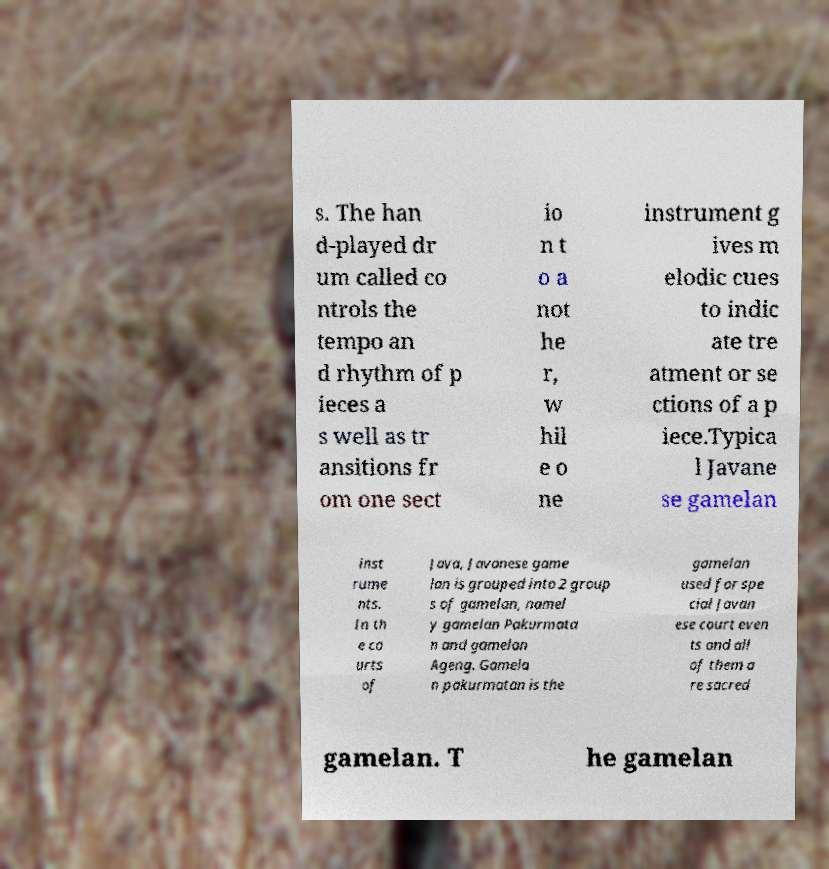Please read and relay the text visible in this image. What does it say? s. The han d-played dr um called co ntrols the tempo an d rhythm of p ieces a s well as tr ansitions fr om one sect io n t o a not he r, w hil e o ne instrument g ives m elodic cues to indic ate tre atment or se ctions of a p iece.Typica l Javane se gamelan inst rume nts. In th e co urts of Java, Javanese game lan is grouped into 2 group s of gamelan, namel y gamelan Pakurmata n and gamelan Ageng. Gamela n pakurmatan is the gamelan used for spe cial Javan ese court even ts and all of them a re sacred gamelan. T he gamelan 